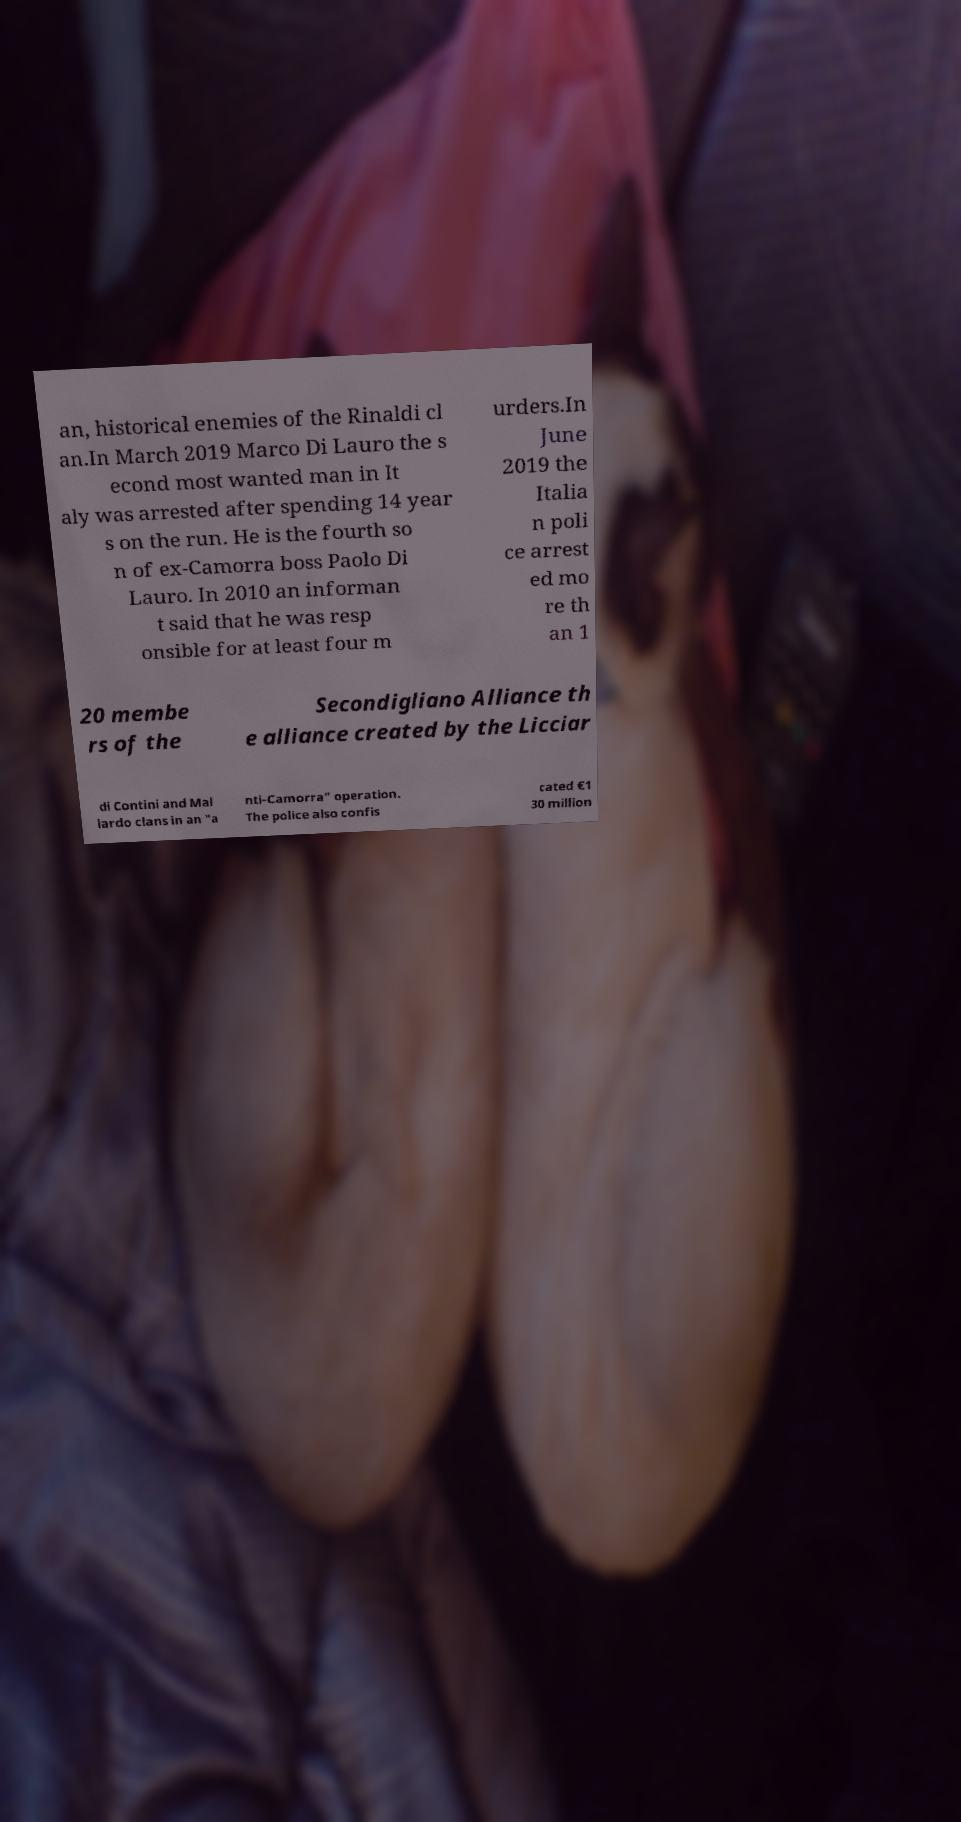Can you accurately transcribe the text from the provided image for me? an, historical enemies of the Rinaldi cl an.In March 2019 Marco Di Lauro the s econd most wanted man in It aly was arrested after spending 14 year s on the run. He is the fourth so n of ex-Camorra boss Paolo Di Lauro. In 2010 an informan t said that he was resp onsible for at least four m urders.In June 2019 the Italia n poli ce arrest ed mo re th an 1 20 membe rs of the Secondigliano Alliance th e alliance created by the Licciar di Contini and Mal lardo clans in an "a nti-Camorra" operation. The police also confis cated €1 30 million 